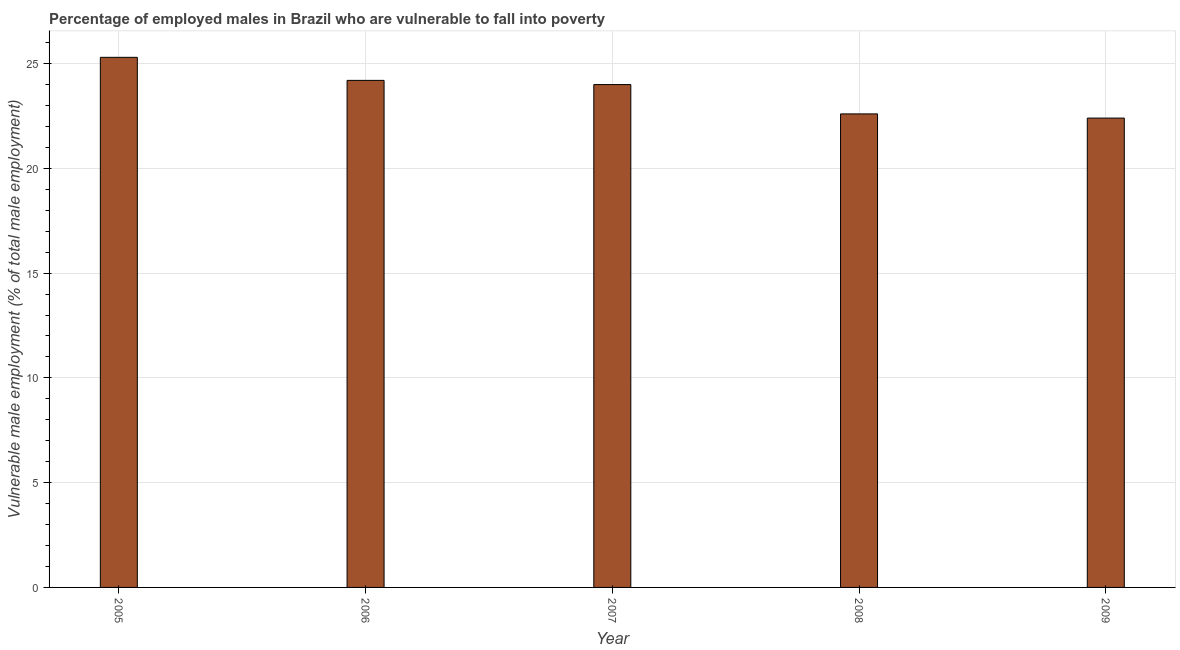Does the graph contain grids?
Offer a terse response. Yes. What is the title of the graph?
Make the answer very short. Percentage of employed males in Brazil who are vulnerable to fall into poverty. What is the label or title of the X-axis?
Your answer should be compact. Year. What is the label or title of the Y-axis?
Make the answer very short. Vulnerable male employment (% of total male employment). What is the percentage of employed males who are vulnerable to fall into poverty in 2005?
Give a very brief answer. 25.3. Across all years, what is the maximum percentage of employed males who are vulnerable to fall into poverty?
Your answer should be very brief. 25.3. Across all years, what is the minimum percentage of employed males who are vulnerable to fall into poverty?
Offer a very short reply. 22.4. In which year was the percentage of employed males who are vulnerable to fall into poverty maximum?
Offer a very short reply. 2005. In which year was the percentage of employed males who are vulnerable to fall into poverty minimum?
Ensure brevity in your answer.  2009. What is the sum of the percentage of employed males who are vulnerable to fall into poverty?
Provide a succinct answer. 118.5. What is the difference between the percentage of employed males who are vulnerable to fall into poverty in 2005 and 2009?
Offer a terse response. 2.9. What is the average percentage of employed males who are vulnerable to fall into poverty per year?
Provide a succinct answer. 23.7. What is the median percentage of employed males who are vulnerable to fall into poverty?
Give a very brief answer. 24. In how many years, is the percentage of employed males who are vulnerable to fall into poverty greater than 5 %?
Your answer should be compact. 5. Do a majority of the years between 2006 and 2005 (inclusive) have percentage of employed males who are vulnerable to fall into poverty greater than 10 %?
Give a very brief answer. No. What is the ratio of the percentage of employed males who are vulnerable to fall into poverty in 2005 to that in 2007?
Your answer should be very brief. 1.05. What is the difference between the highest and the lowest percentage of employed males who are vulnerable to fall into poverty?
Provide a short and direct response. 2.9. How many bars are there?
Give a very brief answer. 5. Are all the bars in the graph horizontal?
Ensure brevity in your answer.  No. Are the values on the major ticks of Y-axis written in scientific E-notation?
Your answer should be very brief. No. What is the Vulnerable male employment (% of total male employment) of 2005?
Provide a short and direct response. 25.3. What is the Vulnerable male employment (% of total male employment) in 2006?
Your response must be concise. 24.2. What is the Vulnerable male employment (% of total male employment) of 2007?
Ensure brevity in your answer.  24. What is the Vulnerable male employment (% of total male employment) in 2008?
Keep it short and to the point. 22.6. What is the Vulnerable male employment (% of total male employment) in 2009?
Provide a short and direct response. 22.4. What is the difference between the Vulnerable male employment (% of total male employment) in 2005 and 2009?
Your response must be concise. 2.9. What is the difference between the Vulnerable male employment (% of total male employment) in 2006 and 2007?
Provide a short and direct response. 0.2. What is the difference between the Vulnerable male employment (% of total male employment) in 2007 and 2008?
Your answer should be very brief. 1.4. What is the difference between the Vulnerable male employment (% of total male employment) in 2007 and 2009?
Ensure brevity in your answer.  1.6. What is the ratio of the Vulnerable male employment (% of total male employment) in 2005 to that in 2006?
Give a very brief answer. 1.04. What is the ratio of the Vulnerable male employment (% of total male employment) in 2005 to that in 2007?
Offer a very short reply. 1.05. What is the ratio of the Vulnerable male employment (% of total male employment) in 2005 to that in 2008?
Give a very brief answer. 1.12. What is the ratio of the Vulnerable male employment (% of total male employment) in 2005 to that in 2009?
Ensure brevity in your answer.  1.13. What is the ratio of the Vulnerable male employment (% of total male employment) in 2006 to that in 2007?
Make the answer very short. 1.01. What is the ratio of the Vulnerable male employment (% of total male employment) in 2006 to that in 2008?
Make the answer very short. 1.07. What is the ratio of the Vulnerable male employment (% of total male employment) in 2007 to that in 2008?
Offer a terse response. 1.06. What is the ratio of the Vulnerable male employment (% of total male employment) in 2007 to that in 2009?
Offer a terse response. 1.07. 